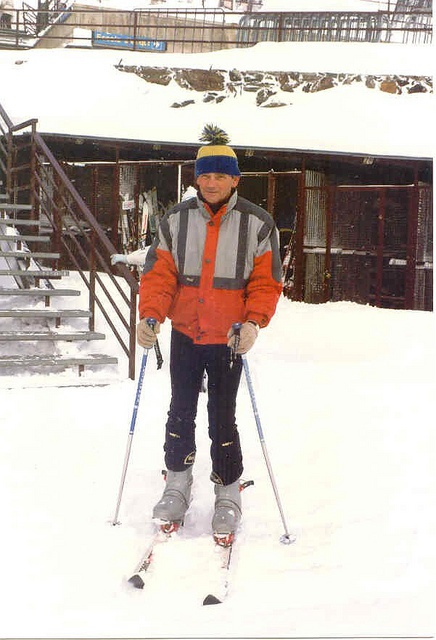Describe the objects in this image and their specific colors. I can see people in ivory, black, darkgray, red, and gray tones and skis in ivory, gray, darkgray, and pink tones in this image. 